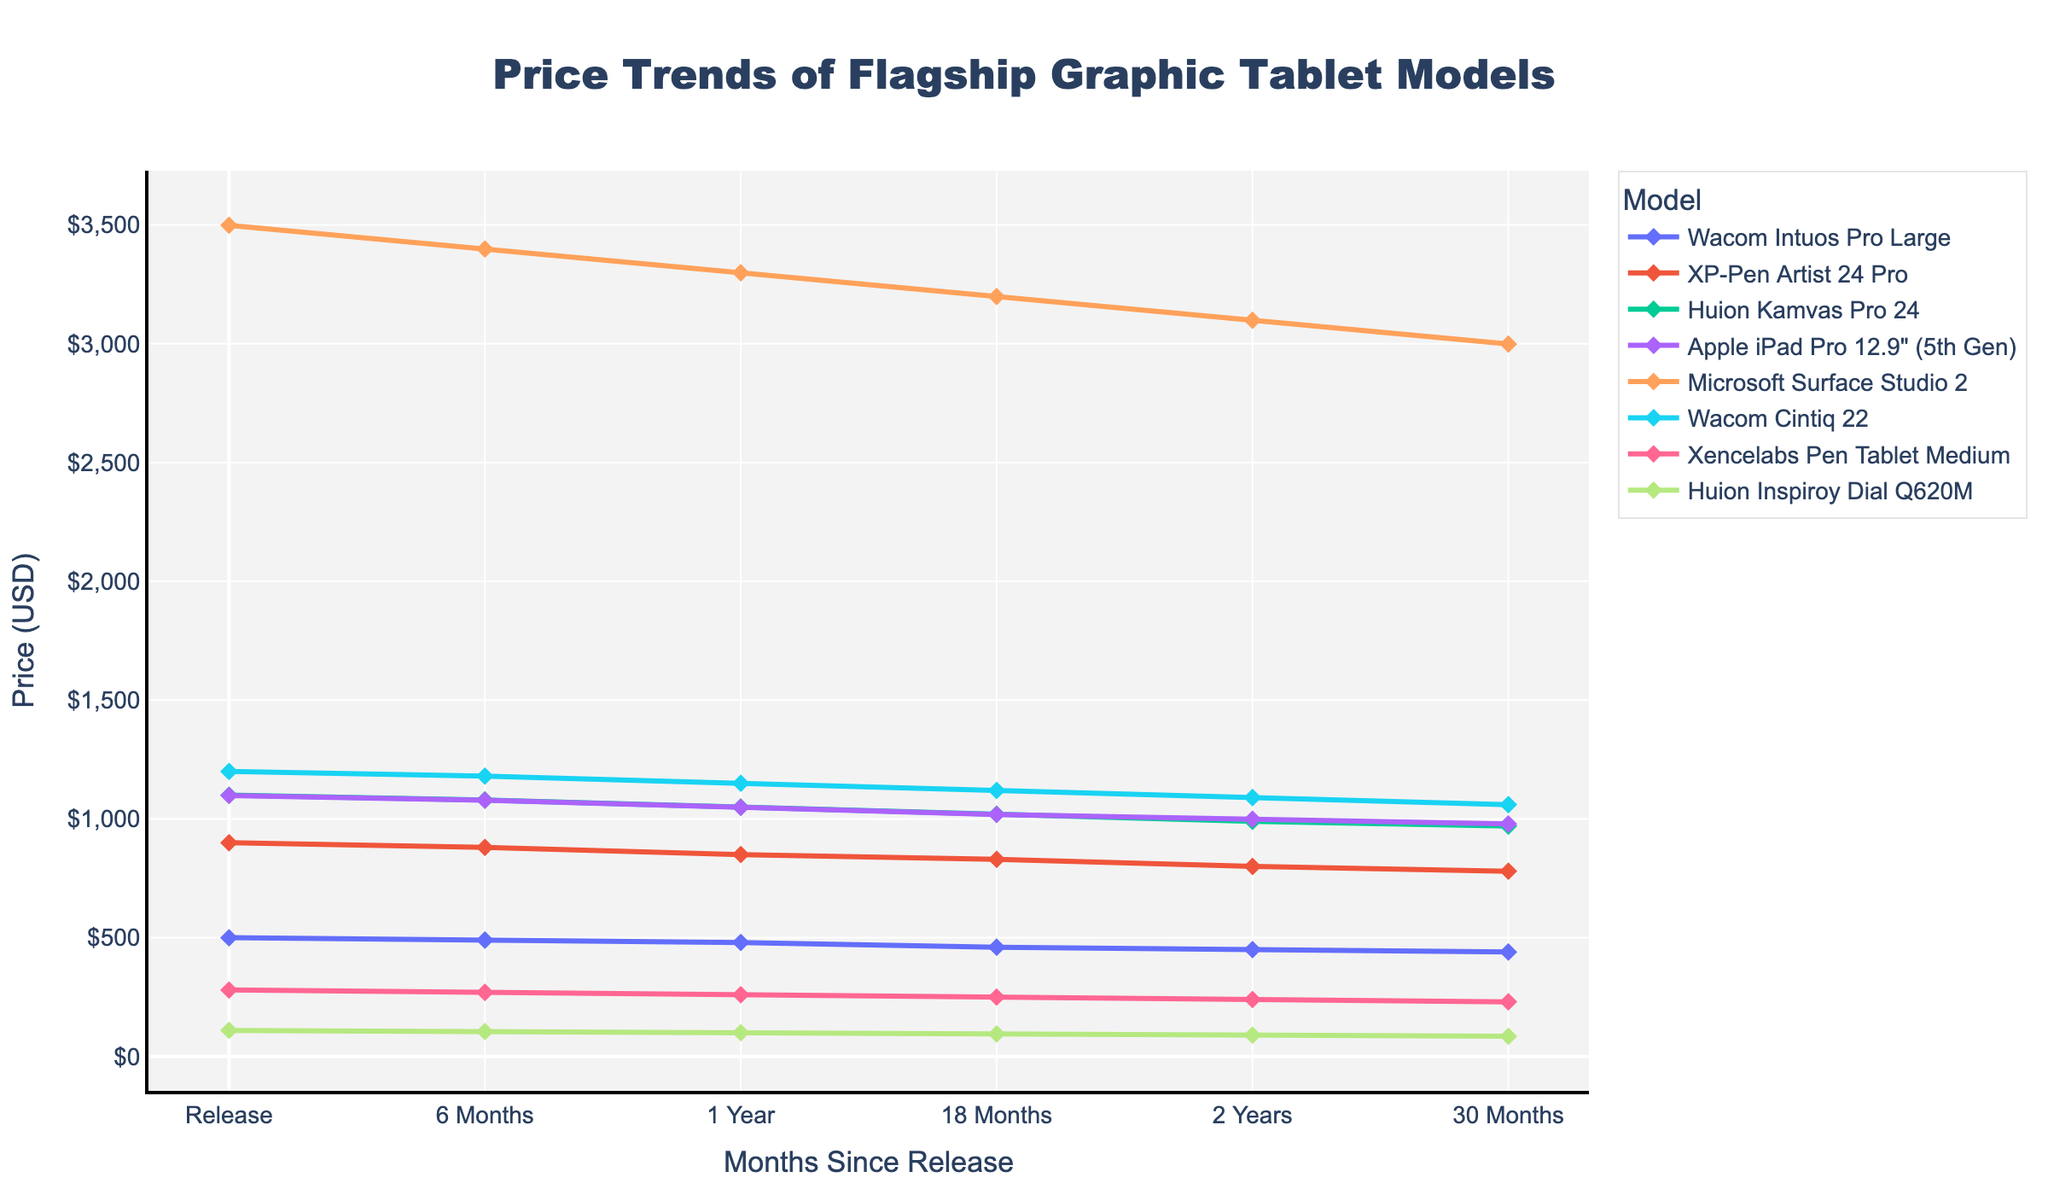What is the price of the Wacom Intuos Pro Large 30 months after its release? To find this, look for the Wacom Intuos Pro Large model line on the graph and locate the price at the 30 months marker.
Answer: $439.99 Which tablet saw the greatest price drop in the first 6 months after release? Compare the initial price and 6-month price for each model, then determine the model with the highest difference.
Answer: Huion Inspiroy Dial Q620M How does the price of the Apple iPad Pro 12.9” (5th Gen) 18 months after release compare to the price of the XP-Pen Artist 24 Pro 1 year after release? First, look for the Apple iPad Pro 12.9” (5th Gen) price at the 18 months marker, then find the XP-Pen Artist 24 Pro price at the 1 year marker and compare the two values.
Answer: Apple iPad Pro 12.9” (5th Gen) is cheaper What is the average price of the Huion Kamvas Pro 24 over the 30 months period? Sum the prices of the Huion Kamvas Pro 24 at all time points (Initial, 6 months, 1 year, 18 months, 2 years, 30 months) and divide by the number of points (6).
Answer: $1034.99 Which model maintains the highest price after 2 years? Identify the model that has the highest price at the 2 years marker by comparing the prices of all models at that specific point.
Answer: Microsoft Surface Studio 2 Is there a model whose price remains above $1000 throughout the 30 months period? Inspect the graph to see if any model line remains consistently above $1000 for all the time points (0 to 30 months).
Answer: Yes, Microsoft Surface Studio 2 By how much did the price of the Wacom Cintiq 22 drop from its initial release to the 2-year mark? Subtract the 2-year price of the Wacom Cintiq 22 from its initial release price.
Answer: $109.96 Compare the initial prices of all the models. Which one had the highest initial price? Look at the initial price values for all models and identify the one with the highest amount.
Answer: Microsoft Surface Studio 2 Which model had the least price fluctuation over the 30 months period? Calculate the difference between the highest and lowest prices for each model over the 30 months and identify the model with the smallest difference.
Answer: Xencelabs Pen Tablet Medium How much did the price of the XP-Pen Artist 24 Pro change from the 1-year mark to the 30-month mark? Subtract the 30-month price of the XP-Pen Artist 24 Pro from its 1-year price.
Answer: $70.00 